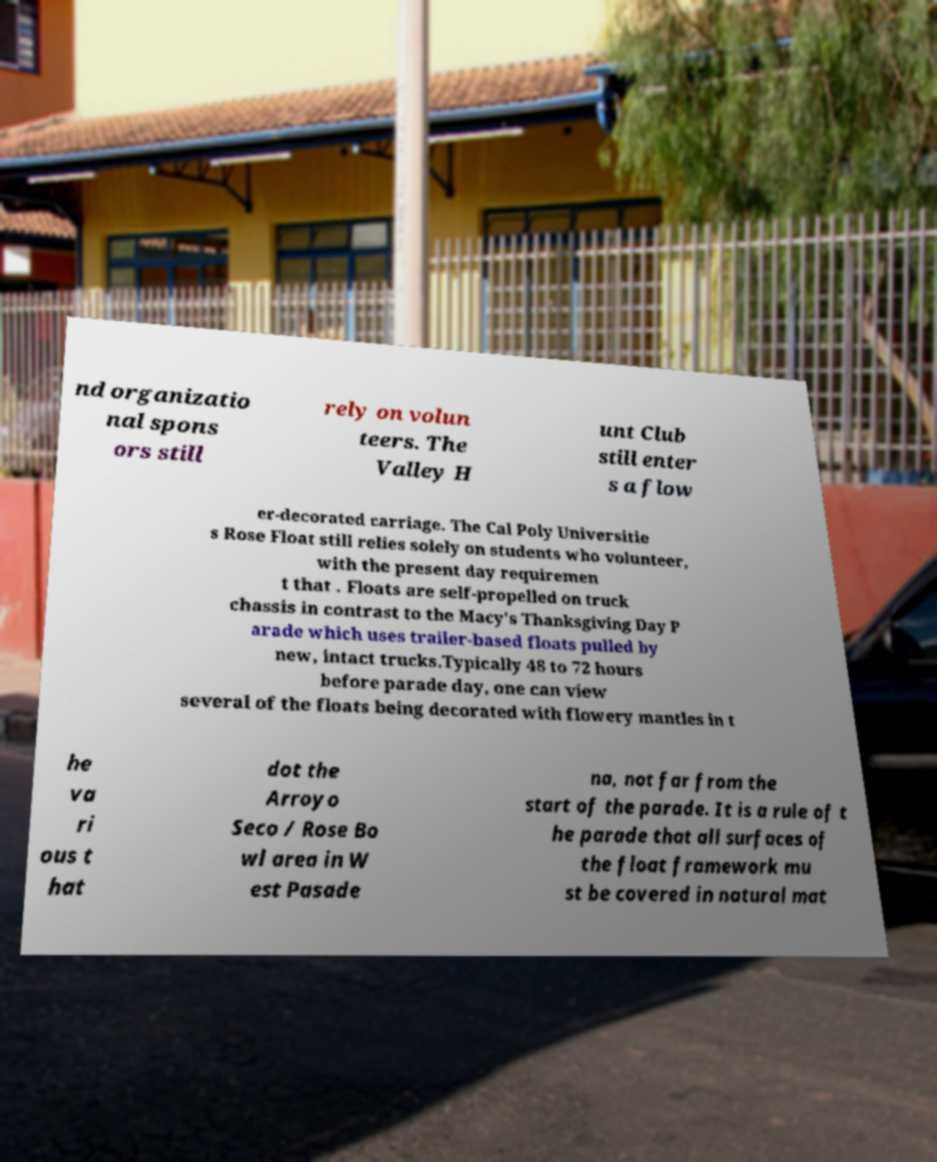Can you read and provide the text displayed in the image?This photo seems to have some interesting text. Can you extract and type it out for me? nd organizatio nal spons ors still rely on volun teers. The Valley H unt Club still enter s a flow er-decorated carriage. The Cal Poly Universitie s Rose Float still relies solely on students who volunteer, with the present day requiremen t that . Floats are self-propelled on truck chassis in contrast to the Macy's Thanksgiving Day P arade which uses trailer-based floats pulled by new, intact trucks.Typically 48 to 72 hours before parade day, one can view several of the floats being decorated with flowery mantles in t he va ri ous t hat dot the Arroyo Seco / Rose Bo wl area in W est Pasade na, not far from the start of the parade. It is a rule of t he parade that all surfaces of the float framework mu st be covered in natural mat 